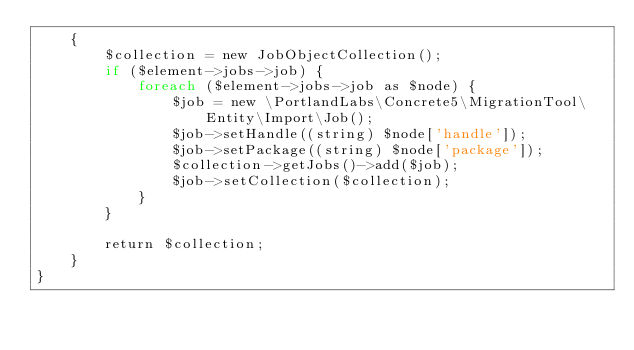Convert code to text. <code><loc_0><loc_0><loc_500><loc_500><_PHP_>    {
        $collection = new JobObjectCollection();
        if ($element->jobs->job) {
            foreach ($element->jobs->job as $node) {
                $job = new \PortlandLabs\Concrete5\MigrationTool\Entity\Import\Job();
                $job->setHandle((string) $node['handle']);
                $job->setPackage((string) $node['package']);
                $collection->getJobs()->add($job);
                $job->setCollection($collection);
            }
        }

        return $collection;
    }
}
</code> 